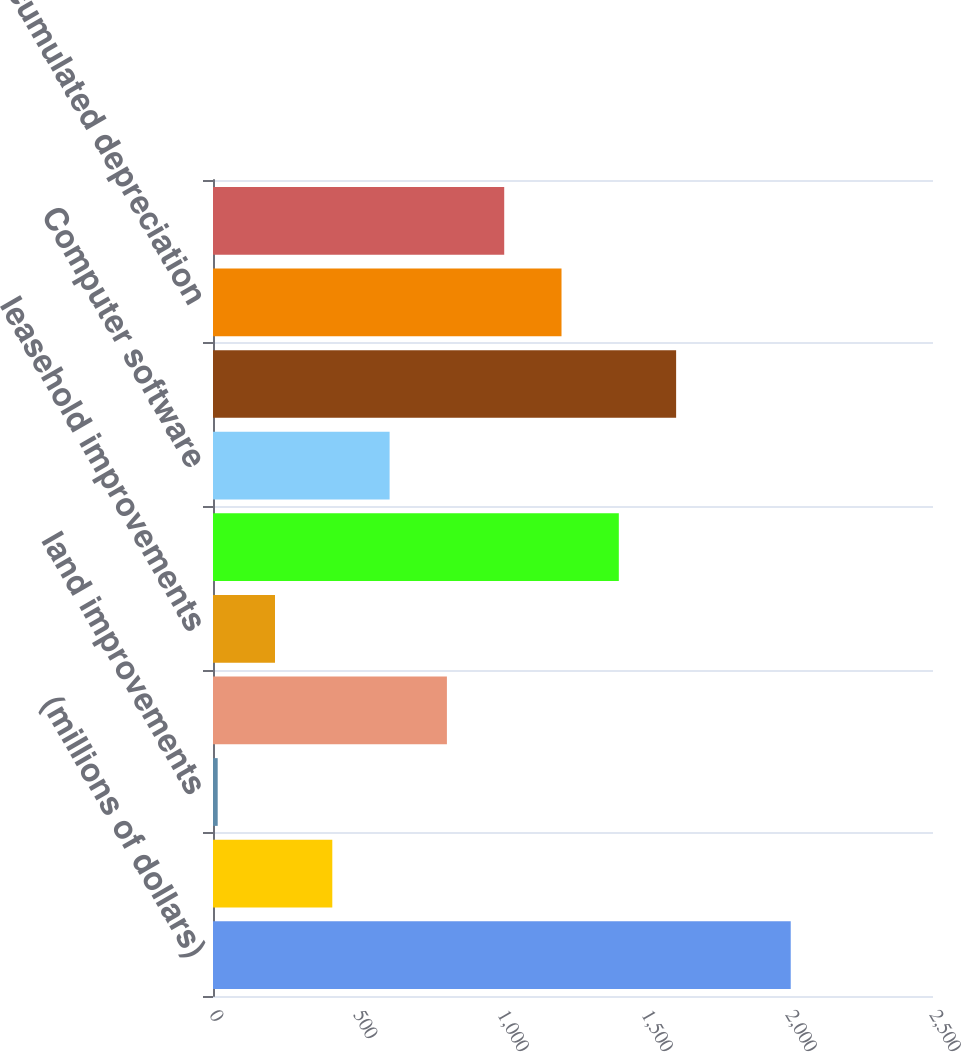Convert chart. <chart><loc_0><loc_0><loc_500><loc_500><bar_chart><fcel>(millions of dollars)<fcel>land<fcel>land improvements<fcel>Buildings<fcel>leasehold improvements<fcel>Machinery and equipment<fcel>Computer software<fcel>Gross pp&e<fcel>less accumulated depreciation<fcel>total<nl><fcel>2006<fcel>414.24<fcel>16.3<fcel>812.18<fcel>215.27<fcel>1409.09<fcel>613.21<fcel>1608.06<fcel>1210.12<fcel>1011.15<nl></chart> 